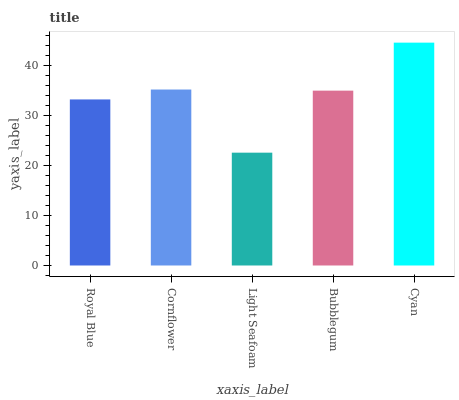Is Cornflower the minimum?
Answer yes or no. No. Is Cornflower the maximum?
Answer yes or no. No. Is Cornflower greater than Royal Blue?
Answer yes or no. Yes. Is Royal Blue less than Cornflower?
Answer yes or no. Yes. Is Royal Blue greater than Cornflower?
Answer yes or no. No. Is Cornflower less than Royal Blue?
Answer yes or no. No. Is Bubblegum the high median?
Answer yes or no. Yes. Is Bubblegum the low median?
Answer yes or no. Yes. Is Royal Blue the high median?
Answer yes or no. No. Is Cornflower the low median?
Answer yes or no. No. 